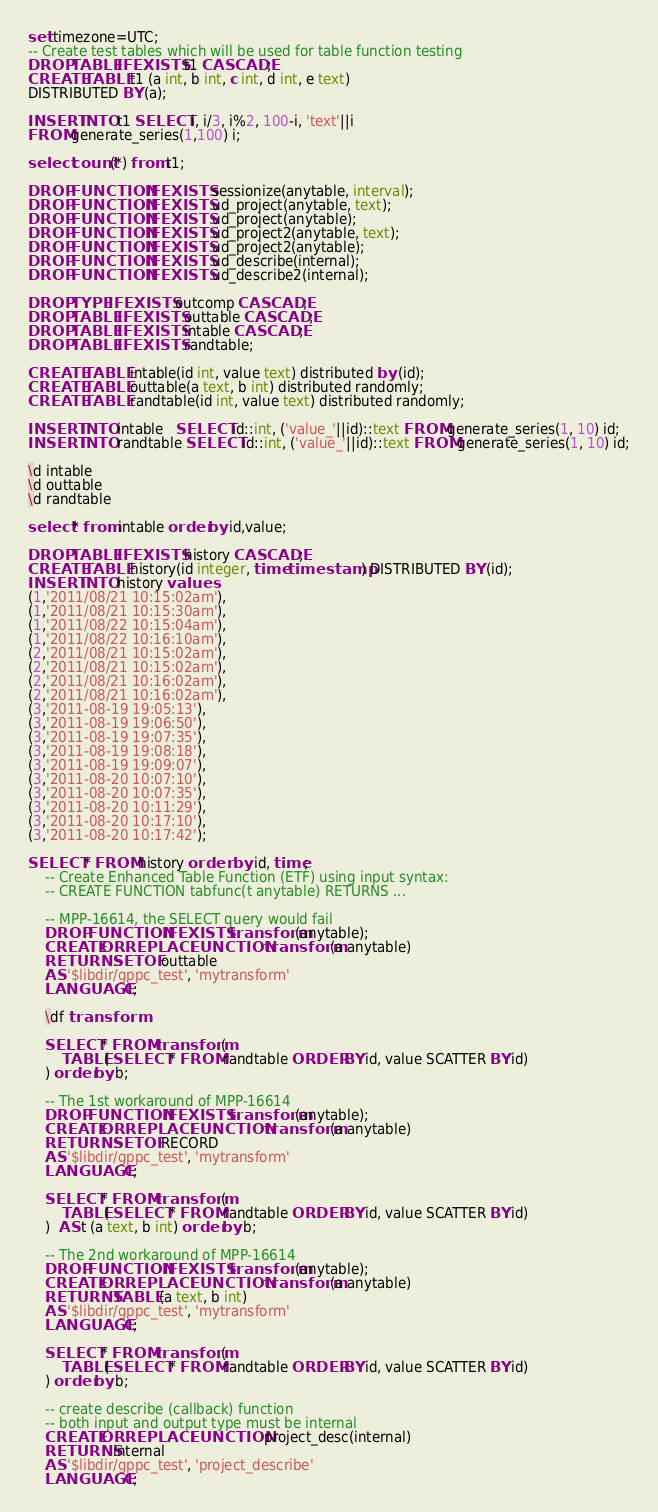<code> <loc_0><loc_0><loc_500><loc_500><_SQL_>set timezone=UTC;
-- Create test tables which will be used for table function testing
DROP TABLE IF EXISTS t1 CASCADE;
CREATE TABLE t1 (a int, b int, c int, d int, e text)
DISTRIBUTED BY (a);

INSERT INTO t1 SELECT i, i/3, i%2, 100-i, 'text'||i 
FROM generate_series(1,100) i;

select count(*) from t1;

DROP FUNCTION IF EXISTS sessionize(anytable, interval);
DROP FUNCTION IF EXISTS ud_project(anytable, text);
DROP FUNCTION IF EXISTS ud_project(anytable);
DROP FUNCTION IF EXISTS ud_project2(anytable, text);
DROP FUNCTION IF EXISTS ud_project2(anytable);
DROP FUNCTION IF EXISTS ud_describe(internal);
DROP FUNCTION IF EXISTS ud_describe2(internal);

DROP TYPE IF EXISTS outcomp CASCADE;
DROP TABLE IF EXISTS outtable CASCADE;
DROP TABLE IF EXISTS intable CASCADE;
DROP TABLE IF EXISTS randtable;

CREATE TABLE intable(id int, value text) distributed by (id);
CREATE TABLE outtable(a text, b int) distributed randomly;
CREATE TABLE randtable(id int, value text) distributed randomly;

INSERT INTO intable   SELECT id::int, ('value_'||id)::text FROM generate_series(1, 10) id;
INSERT INTO randtable SELECT id::int, ('value_'||id)::text FROM generate_series(1, 10) id;

\d intable
\d outtable
\d randtable

select * from intable order by id,value;

DROP TABLE IF EXISTS history CASCADE;
CREATE TABLE history(id integer, time timestamp) DISTRIBUTED BY (id);
INSERT INTO history values 
(1,'2011/08/21 10:15:02am'),
(1,'2011/08/21 10:15:30am'),
(1,'2011/08/22 10:15:04am'),
(1,'2011/08/22 10:16:10am'),
(2,'2011/08/21 10:15:02am'),
(2,'2011/08/21 10:15:02am'),
(2,'2011/08/21 10:16:02am'),
(2,'2011/08/21 10:16:02am'),
(3,'2011-08-19 19:05:13'),
(3,'2011-08-19 19:06:50'),
(3,'2011-08-19 19:07:35'),
(3,'2011-08-19 19:08:18'),
(3,'2011-08-19 19:09:07'),
(3,'2011-08-20 10:07:10'),
(3,'2011-08-20 10:07:35'),
(3,'2011-08-20 10:11:29'),
(3,'2011-08-20 10:17:10'),
(3,'2011-08-20 10:17:42');

SELECT * FROM history order  by id, time;
    -- Create Enhanced Table Function (ETF) using input syntax: 
    -- CREATE FUNCTION tabfunc(t anytable) RETURNS ...

    -- MPP-16614, the SELECT query would fail
    DROP FUNCTION IF EXISTS transform(anytable);
    CREATE OR REPLACE FUNCTION transform(a anytable)
    RETURNS SETOF outtable
    AS '$libdir/gppc_test', 'mytransform'
    LANGUAGE C;

    \df transform

    SELECT * FROM transform( 
        TABLE( SELECT * FROM randtable ORDER BY id, value SCATTER BY id) 
    ) order by b;

    -- The 1st workaround of MPP-16614
    DROP FUNCTION IF EXISTS transform(anytable);
    CREATE OR REPLACE FUNCTION transform(a anytable)
    RETURNS SETOF RECORD
    AS '$libdir/gppc_test', 'mytransform'
    LANGUAGE C;

    SELECT * FROM transform( 
        TABLE( SELECT * FROM randtable ORDER BY id, value SCATTER BY id) 
    )  AS t (a text, b int) order by b;

    -- The 2nd workaround of MPP-16614
    DROP FUNCTION IF EXISTS transform(anytable);
    CREATE OR REPLACE FUNCTION transform(a anytable)
    RETURNS TABLE (a text, b int)
    AS '$libdir/gppc_test', 'mytransform'
    LANGUAGE C;

    SELECT * FROM transform(
        TABLE( SELECT * FROM randtable ORDER BY id, value SCATTER BY id)
    ) order by b;

    -- create describe (callback) function
    -- both input and output type must be internal
    CREATE OR REPLACE FUNCTION project_desc(internal)
    RETURNS internal
    AS '$libdir/gppc_test', 'project_describe'
    LANGUAGE C;
</code> 